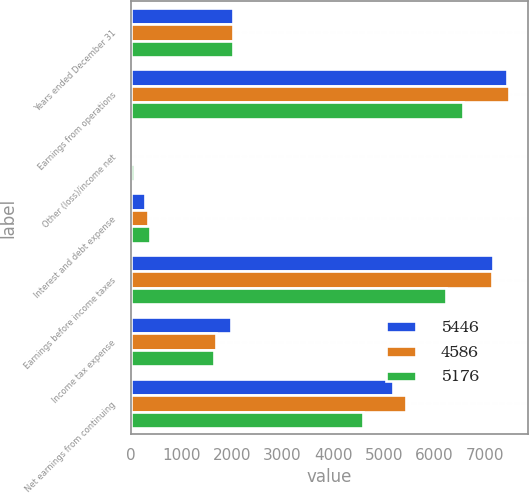<chart> <loc_0><loc_0><loc_500><loc_500><stacked_bar_chart><ecel><fcel>Years ended December 31<fcel>Earnings from operations<fcel>Other (loss)/income net<fcel>Interest and debt expense<fcel>Earnings before income taxes<fcel>Income tax expense<fcel>Net earnings from continuing<nl><fcel>5446<fcel>2015<fcel>7443<fcel>13<fcel>275<fcel>7155<fcel>1979<fcel>5176<nl><fcel>4586<fcel>2014<fcel>7473<fcel>3<fcel>333<fcel>7137<fcel>1691<fcel>5446<nl><fcel>5176<fcel>2013<fcel>6562<fcel>56<fcel>386<fcel>6232<fcel>1646<fcel>4586<nl></chart> 